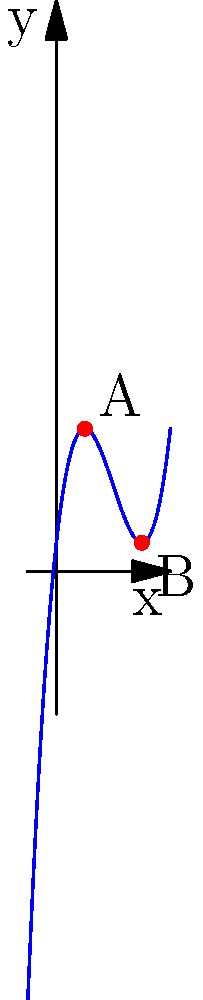As a document legibility expert, you're analyzing the rate of change in font size across different sections of a report. The graph represents the relationship between document section (x-axis) and font size (y-axis). Calculate the difference in the instantaneous rate of change of font size at points A and B. How would this difference impact the document's readability? To solve this problem, we'll follow these steps:

1) The function appears to be a cubic function of the form $f(x) = x^3 - 6x^2 + 9x + 1$.

2) To find the instantaneous rate of change, we need to calculate the derivative:
   $f'(x) = 3x^2 - 12x + 9$

3) Point A is at x = 1, and point B is at x = 3.

4) Calculate f'(1):
   $f'(1) = 3(1)^2 - 12(1) + 9 = 3 - 12 + 9 = 0$

5) Calculate f'(3):
   $f'(3) = 3(3)^2 - 12(3) + 9 = 27 - 36 + 9 = 0$

6) The difference in rates of change:
   $f'(3) - f'(1) = 0 - 0 = 0$

7) Impact on readability:
   Since the difference in rates of change is zero, the font size is changing at the same rate at both points. This consistency in rate of change could contribute to a smooth transition in font sizes across the document, potentially enhancing overall readability.
Answer: 0; consistent rate of change may improve readability 